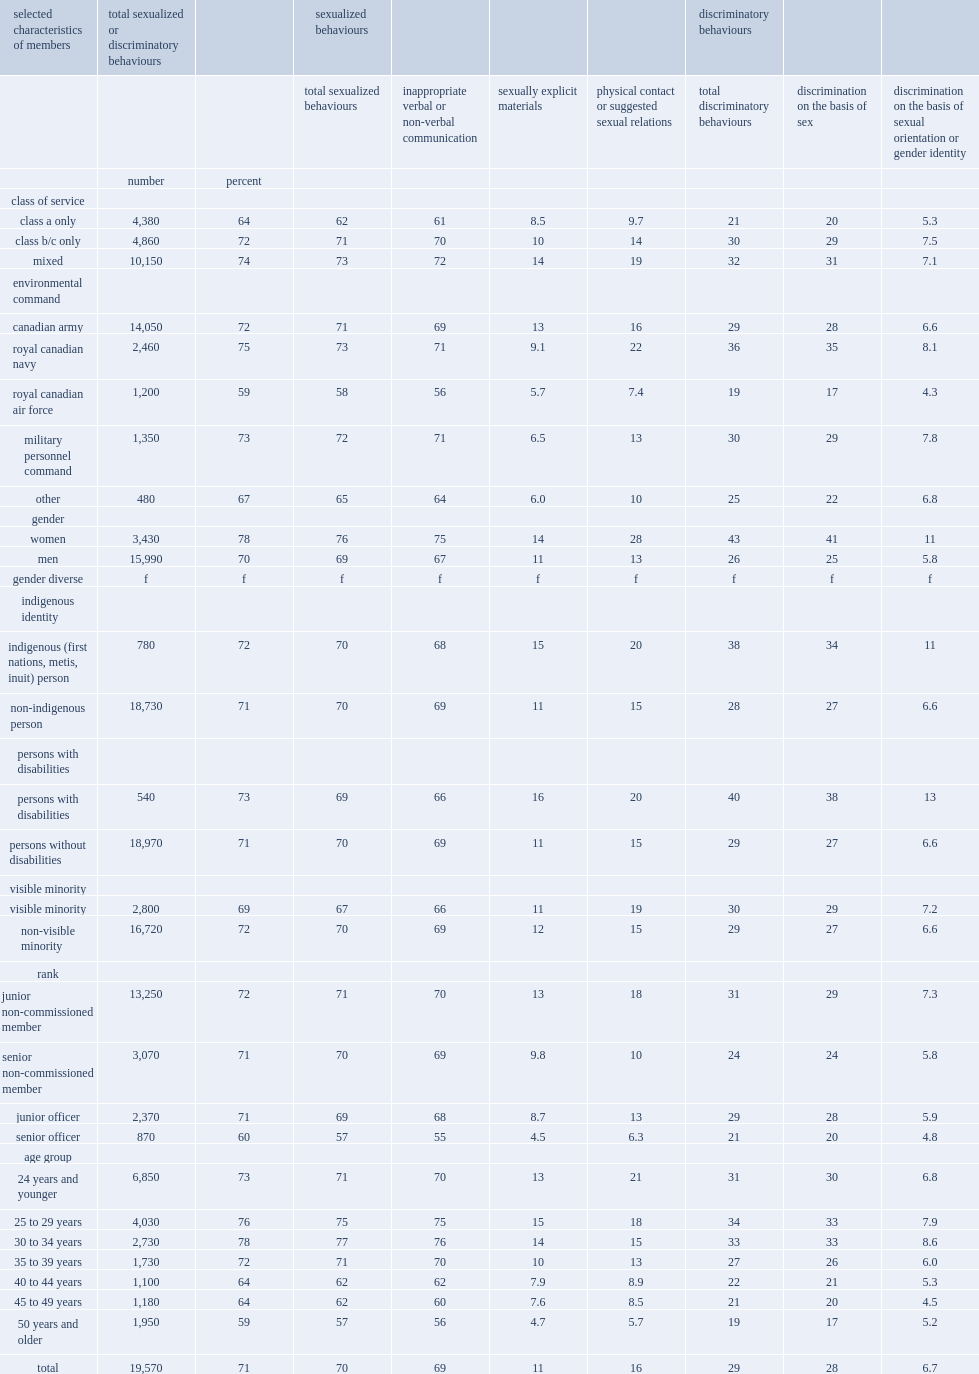Which kind of reservists reported a lower prevalence of witnessing or experiencing sexualized behaviours, who worked part-time only (class a) or who worked exclusively full-time (class b and/or c)? Class a only. Which kind of reservists reported a lower prevalence of witnessing or experiencing sexualized behaviours, who worked part-time only (class a) or who worked a combination of part-time and full-time? Class a only. 